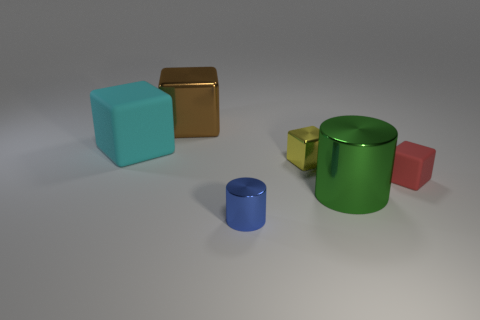Subtract all red rubber cubes. How many cubes are left? 3 Subtract all brown cubes. How many cubes are left? 3 Add 4 tiny cubes. How many objects exist? 10 Subtract all small purple metal objects. Subtract all big things. How many objects are left? 3 Add 1 brown metal objects. How many brown metal objects are left? 2 Add 2 cyan blocks. How many cyan blocks exist? 3 Subtract 0 yellow spheres. How many objects are left? 6 Subtract all cylinders. How many objects are left? 4 Subtract 3 blocks. How many blocks are left? 1 Subtract all blue blocks. Subtract all cyan spheres. How many blocks are left? 4 